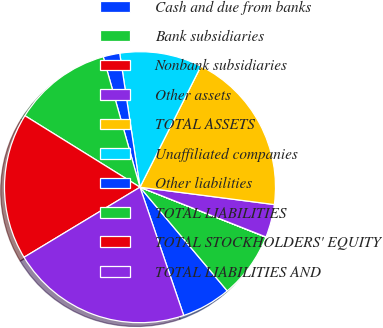Convert chart. <chart><loc_0><loc_0><loc_500><loc_500><pie_chart><fcel>Cash and due from banks<fcel>Bank subsidiaries<fcel>Nonbank subsidiaries<fcel>Other assets<fcel>TOTAL ASSETS<fcel>Unaffiliated companies<fcel>Other liabilities<fcel>TOTAL LIABILITIES<fcel>TOTAL STOCKHOLDERS' EQUITY<fcel>TOTAL LIABILITIES AND<nl><fcel>5.9%<fcel>7.86%<fcel>0.02%<fcel>3.94%<fcel>19.62%<fcel>9.82%<fcel>1.98%<fcel>11.78%<fcel>17.5%<fcel>21.58%<nl></chart> 